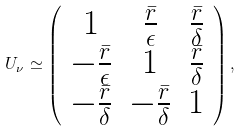Convert formula to latex. <formula><loc_0><loc_0><loc_500><loc_500>U _ { \nu } \simeq \left ( \begin{array} { c c c } 1 & \frac { \bar { r } } { \epsilon } & \frac { \bar { r } } { \delta } \\ - \frac { \bar { r } } { \epsilon } & 1 & \frac { \bar { r } } { \delta } \\ - \frac { \bar { r } } { \delta } & - \frac { \bar { r } } { \delta } & 1 \end{array} \right ) ,</formula> 